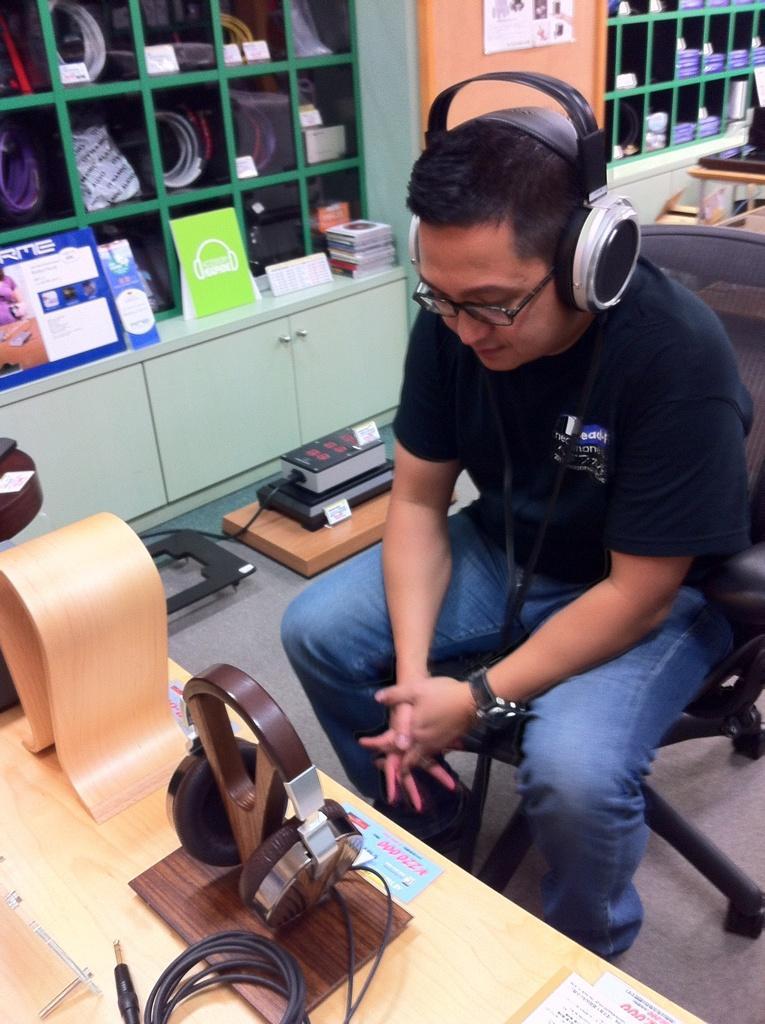In one or two sentences, can you explain what this image depicts? In this picture we can see a man, he is seated on the chair, and he wore a headset, i front of him we can find headphones, papers and other things on the table, beside to him we can see few other things in the racks. 